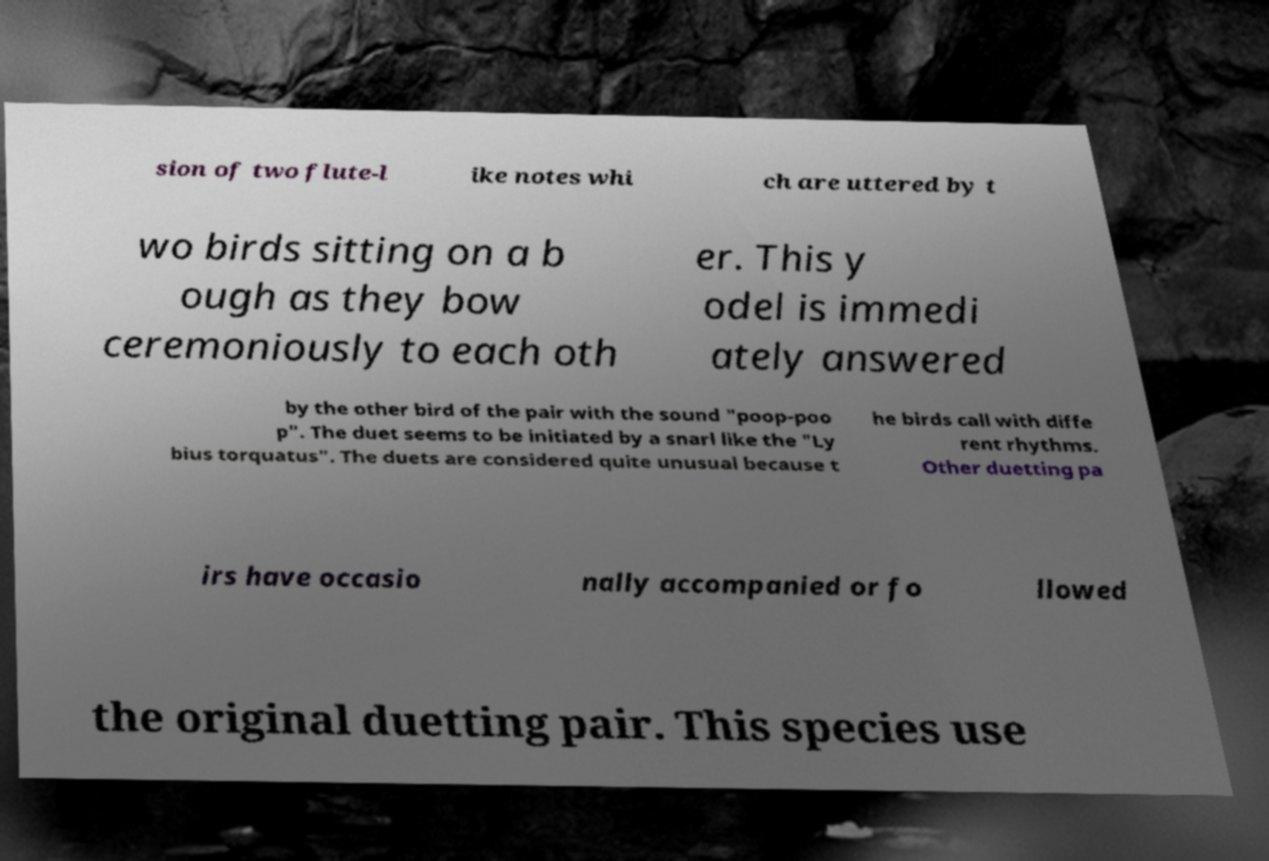Can you accurately transcribe the text from the provided image for me? sion of two flute-l ike notes whi ch are uttered by t wo birds sitting on a b ough as they bow ceremoniously to each oth er. This y odel is immedi ately answered by the other bird of the pair with the sound "poop-poo p". The duet seems to be initiated by a snarl like the "Ly bius torquatus". The duets are considered quite unusual because t he birds call with diffe rent rhythms. Other duetting pa irs have occasio nally accompanied or fo llowed the original duetting pair. This species use 